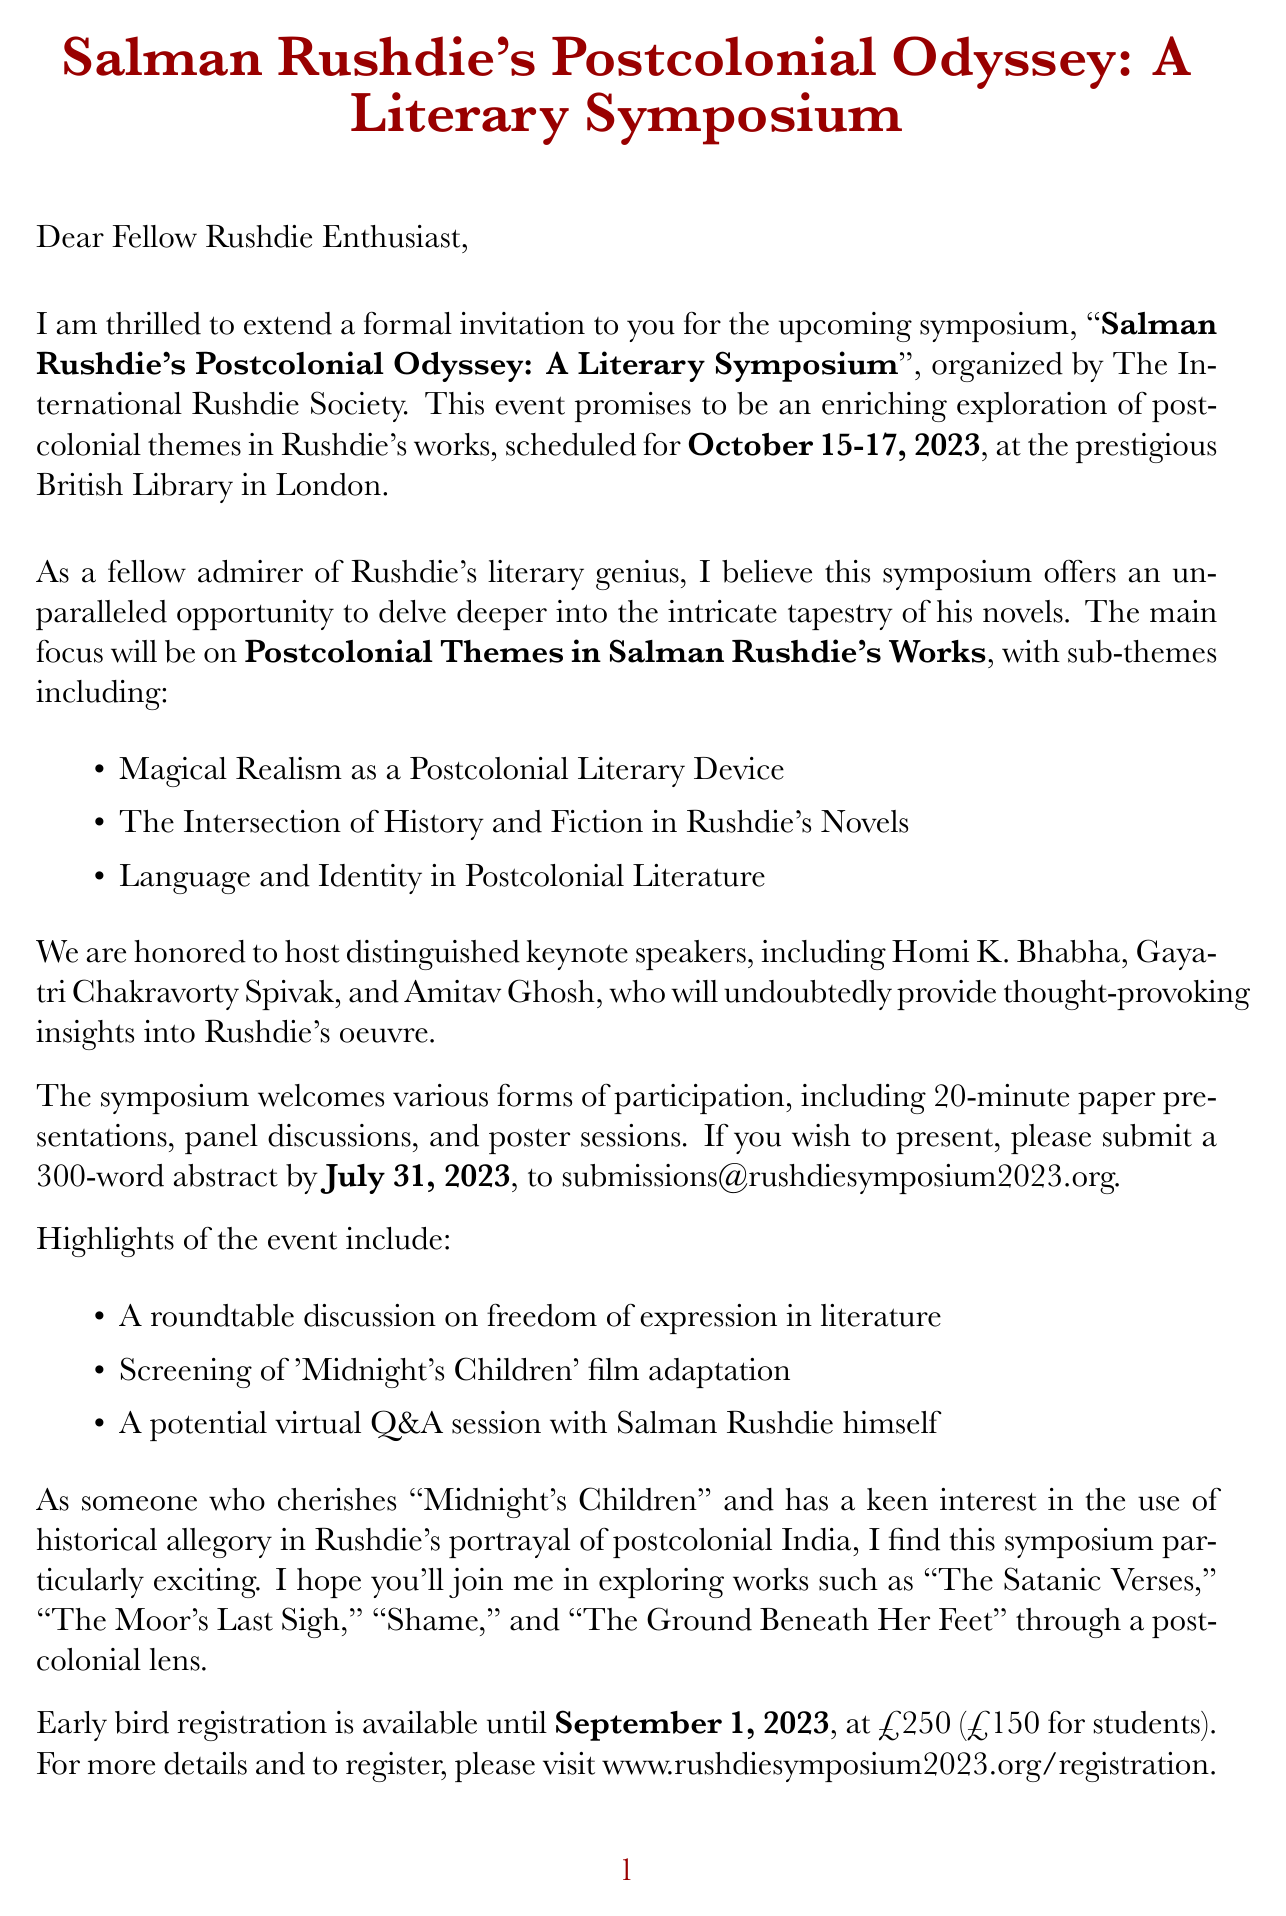What are the dates of the symposium? The dates of the symposium are explicitly stated in the document as "October 15-17, 2023."
Answer: October 15-17, 2023 Who is the organizer of the event? The document clearly identifies "The International Rushdie Society" as the organizer of the symposium.
Answer: The International Rushdie Society What is the main theme of the symposium? The main theme is outlined in the document as "Postcolonial Themes in Salman Rushdie's Works."
Answer: Postcolonial Themes in Salman Rushdie's Works What is the submission deadline for abstracts? The document specifies that the submission deadline for abstracts is "July 31, 2023."
Answer: July 31, 2023 What type of session is NOT mentioned as a participation format? The document lists several formats for participation but does not include "workshops."
Answer: workshops Who are the key speakers at the event? The names of the key speakers are listed in the document, which includes Homi K. Bhabha, Gayatri Chakravorty Spivak, and Amitav Ghosh.
Answer: Homi K. Bhabha, Gayatri Chakravorty Spivak, Amitav Ghosh What is the early bird registration fee? The early bird registration fee is mentioned in the document as £250.
Answer: £250 What film adaptation will be screened at the symposium? The document states that there will be a screening of "Midnight's Children."
Answer: Midnight's Children What is the word limit for the abstract submission? The document indicates that the abstract length should be "300 words."
Answer: 300 words 